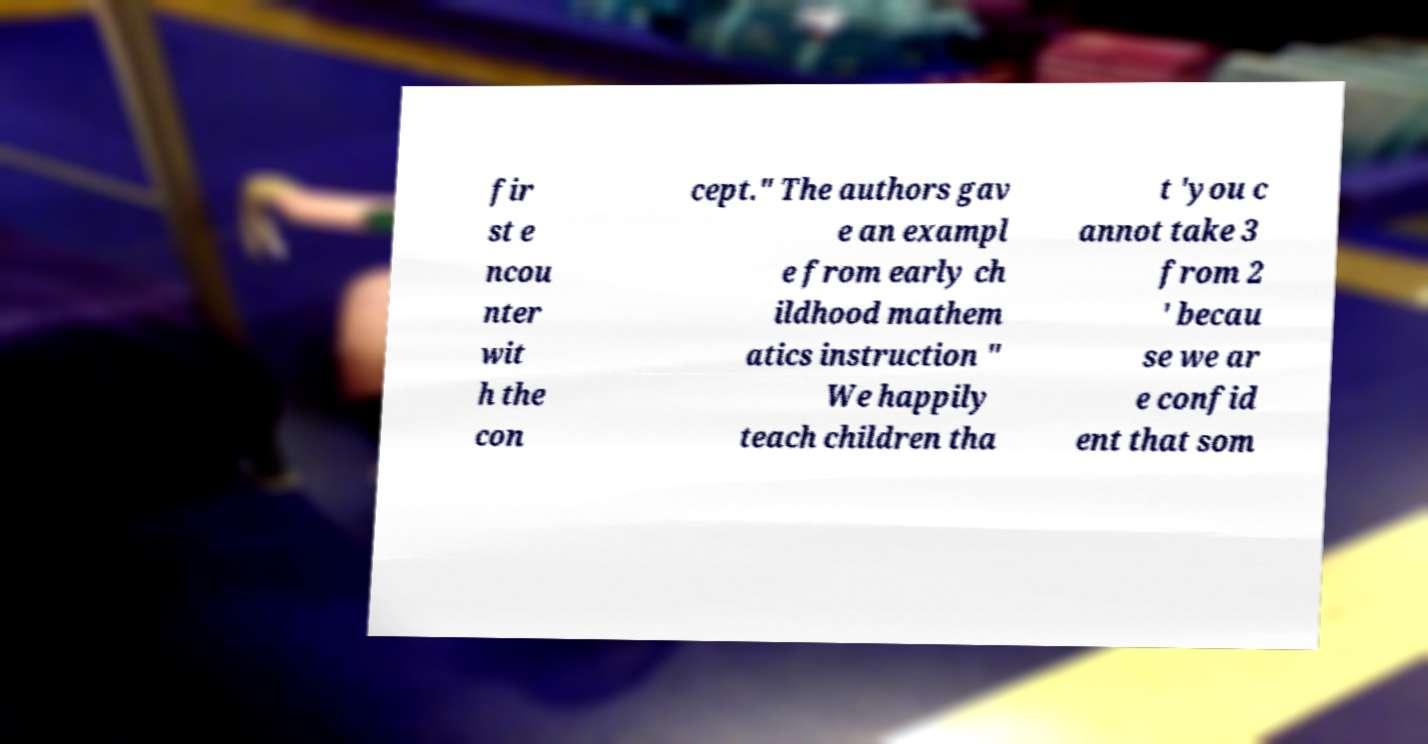Could you extract and type out the text from this image? fir st e ncou nter wit h the con cept." The authors gav e an exampl e from early ch ildhood mathem atics instruction " We happily teach children tha t 'you c annot take 3 from 2 ' becau se we ar e confid ent that som 